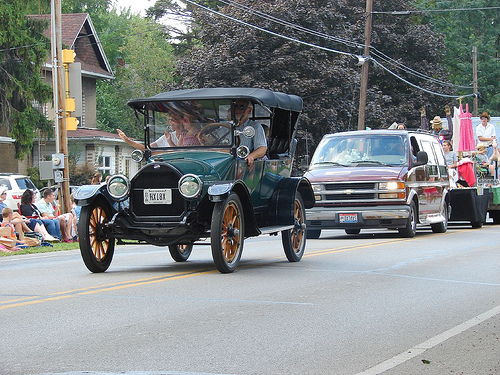<image>
Is there a telephone pole on the car? No. The telephone pole is not positioned on the car. They may be near each other, but the telephone pole is not supported by or resting on top of the car. Is there a people to the right of the van? No. The people is not to the right of the van. The horizontal positioning shows a different relationship. 